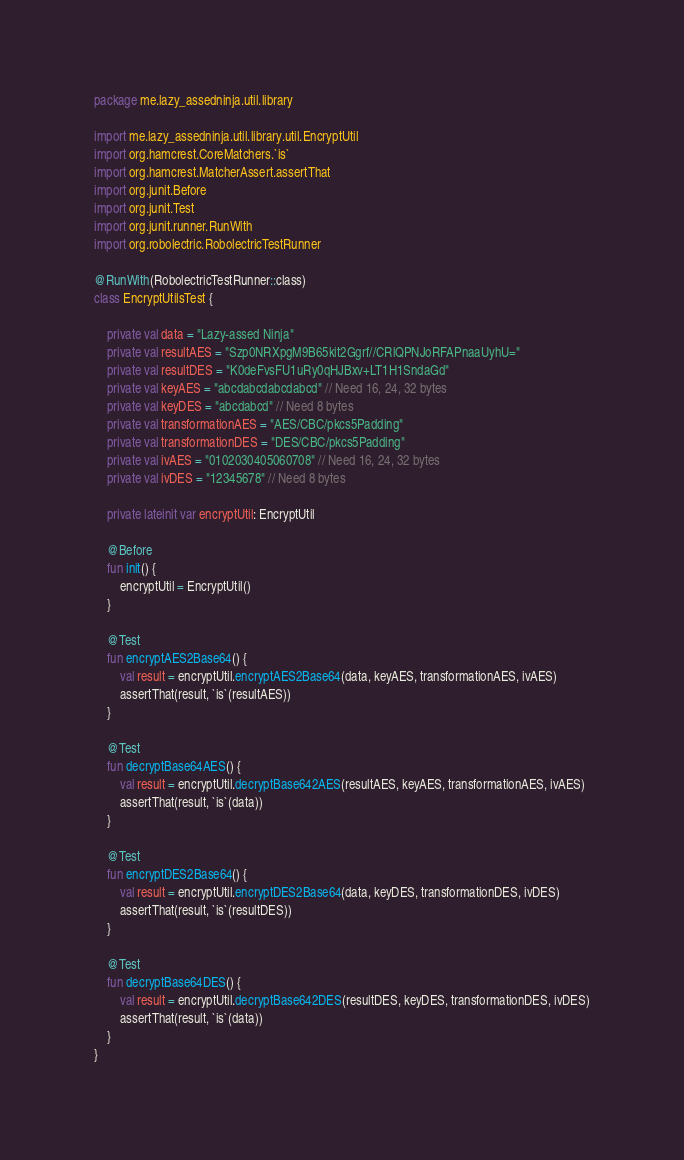<code> <loc_0><loc_0><loc_500><loc_500><_Kotlin_>package me.lazy_assedninja.util.library

import me.lazy_assedninja.util.library.util.EncryptUtil
import org.hamcrest.CoreMatchers.`is`
import org.hamcrest.MatcherAssert.assertThat
import org.junit.Before
import org.junit.Test
import org.junit.runner.RunWith
import org.robolectric.RobolectricTestRunner

@RunWith(RobolectricTestRunner::class)
class EncryptUtilsTest {

    private val data = "Lazy-assed Ninja"
    private val resultAES = "Szp0NRXpgM9B65kit2Ggrf//CRlQPNJoRFAPnaaUyhU="
    private val resultDES = "K0deFvsFU1uRy0qHJBxv+LT1H1SndaGd"
    private val keyAES = "abcdabcdabcdabcd" // Need 16, 24, 32 bytes
    private val keyDES = "abcdabcd" // Need 8 bytes
    private val transformationAES = "AES/CBC/pkcs5Padding"
    private val transformationDES = "DES/CBC/pkcs5Padding"
    private val ivAES = "0102030405060708" // Need 16, 24, 32 bytes
    private val ivDES = "12345678" // Need 8 bytes

    private lateinit var encryptUtil: EncryptUtil

    @Before
    fun init() {
        encryptUtil = EncryptUtil()
    }

    @Test
    fun encryptAES2Base64() {
        val result = encryptUtil.encryptAES2Base64(data, keyAES, transformationAES, ivAES)
        assertThat(result, `is`(resultAES))
    }

    @Test
    fun decryptBase64AES() {
        val result = encryptUtil.decryptBase642AES(resultAES, keyAES, transformationAES, ivAES)
        assertThat(result, `is`(data))
    }

    @Test
    fun encryptDES2Base64() {
        val result = encryptUtil.encryptDES2Base64(data, keyDES, transformationDES, ivDES)
        assertThat(result, `is`(resultDES))
    }

    @Test
    fun decryptBase64DES() {
        val result = encryptUtil.decryptBase642DES(resultDES, keyDES, transformationDES, ivDES)
        assertThat(result, `is`(data))
    }
}</code> 